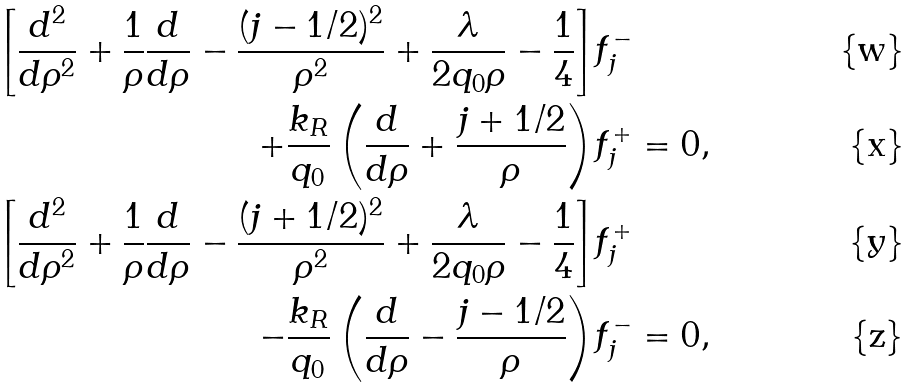<formula> <loc_0><loc_0><loc_500><loc_500>\left [ \frac { d ^ { 2 } } { d \rho ^ { 2 } } + \frac { 1 } { \rho } \frac { d } { d \rho } - \frac { ( j - 1 / 2 ) ^ { 2 } } { \rho ^ { 2 } } + \frac { \lambda } { 2 q _ { 0 } \rho } - \frac { 1 } { 4 } \right ] & f _ { j } ^ { - } \\ + \frac { k _ { R } } { q _ { 0 } } \left ( \frac { d } { d \rho } + \frac { j + 1 / 2 } { \rho } \right ) & f _ { j } ^ { + } = 0 , \\ \left [ \frac { d ^ { 2 } } { d \rho ^ { 2 } } + \frac { 1 } { \rho } \frac { d } { d \rho } - \frac { ( j + 1 / 2 ) ^ { 2 } } { \rho ^ { 2 } } + \frac { \lambda } { 2 q _ { 0 } \rho } - \frac { 1 } { 4 } \right ] & f _ { j } ^ { + } \\ - \frac { k _ { R } } { q _ { 0 } } \left ( \frac { d } { d \rho } - \frac { j - 1 / 2 } { \rho } \right ) & f _ { j } ^ { - } = 0 ,</formula> 